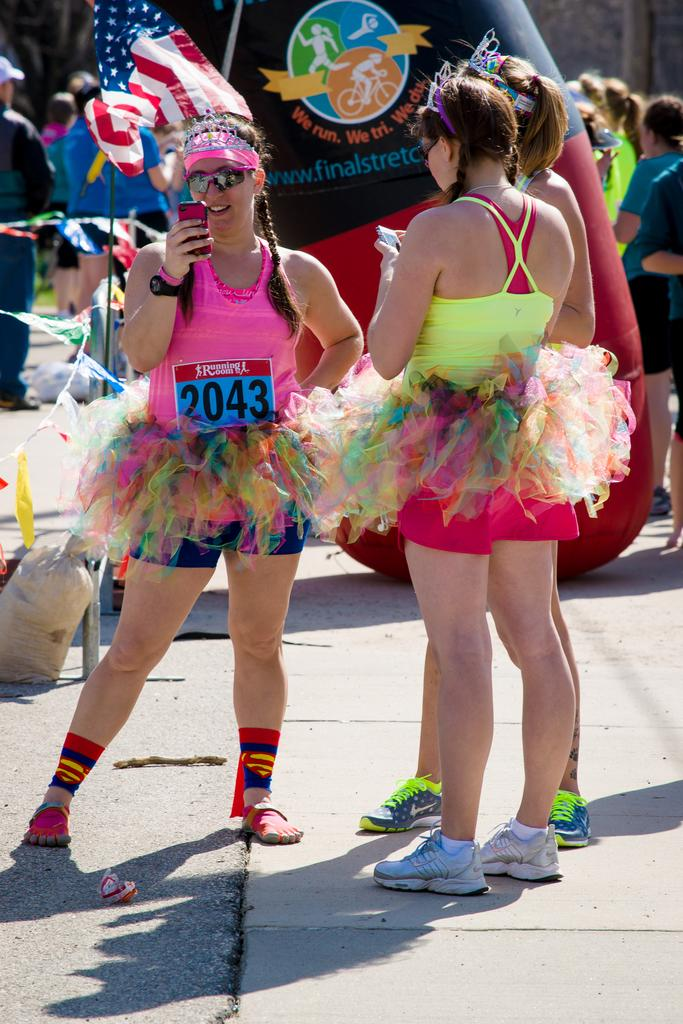How many people are present in the image? There are people in the image, but the exact number is not specified. What are some of the people holding in the image? Some people are holding objects in the image, but the specific objects are not mentioned. Can you describe the bag in the image? There is a bag in the image, but its appearance or contents are not described. What is the flag like in the image? There is a flag in the image, but its design, color, or size is not specified. What are the other unspecified objects in the image? There are other unspecified objects in the image, but their nature or appearance is not described. What degree does the person driving the car in the image have? There is no mention of a car or a person driving in the image, so it is not possible to answer this question. 